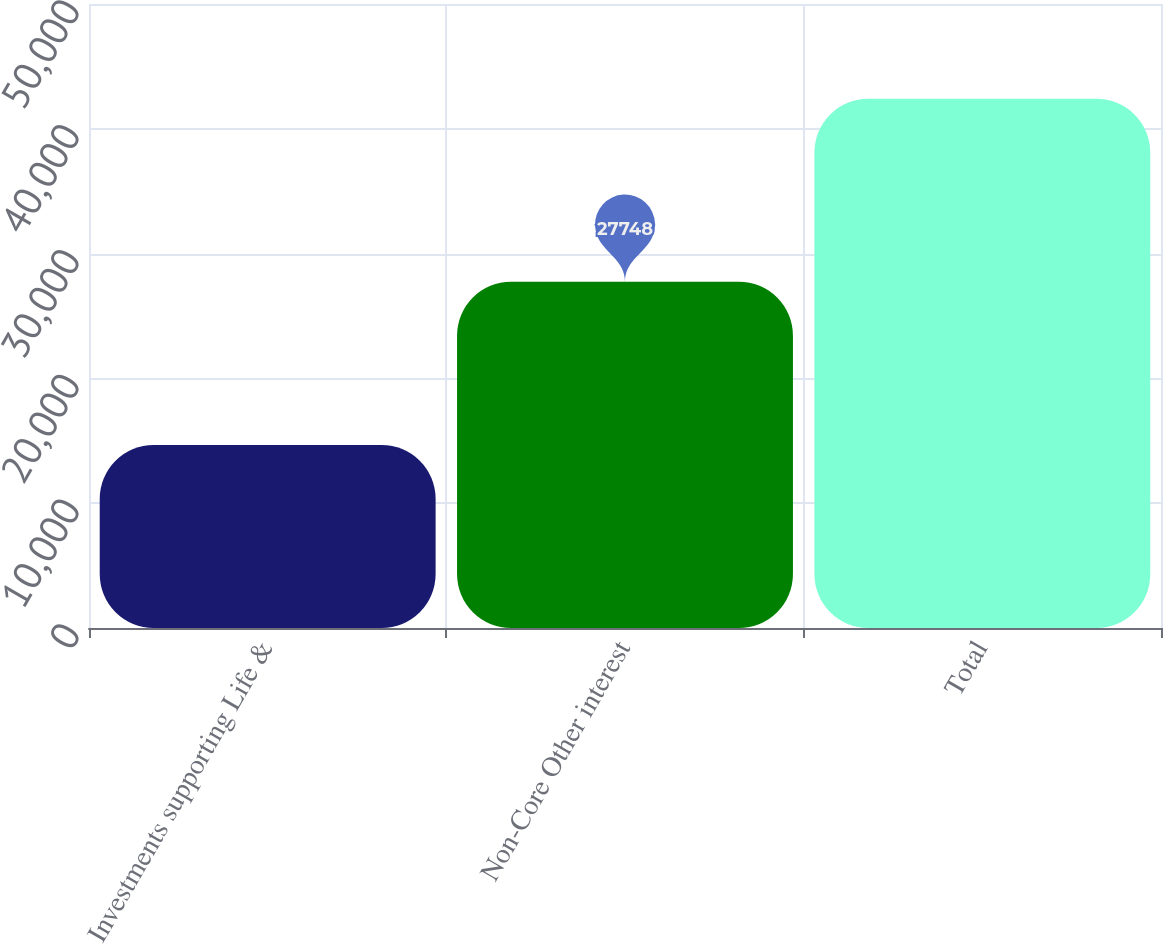<chart> <loc_0><loc_0><loc_500><loc_500><bar_chart><fcel>Investments supporting Life &<fcel>Non-Core Other interest<fcel>Total<nl><fcel>14668<fcel>27748<fcel>42416<nl></chart> 